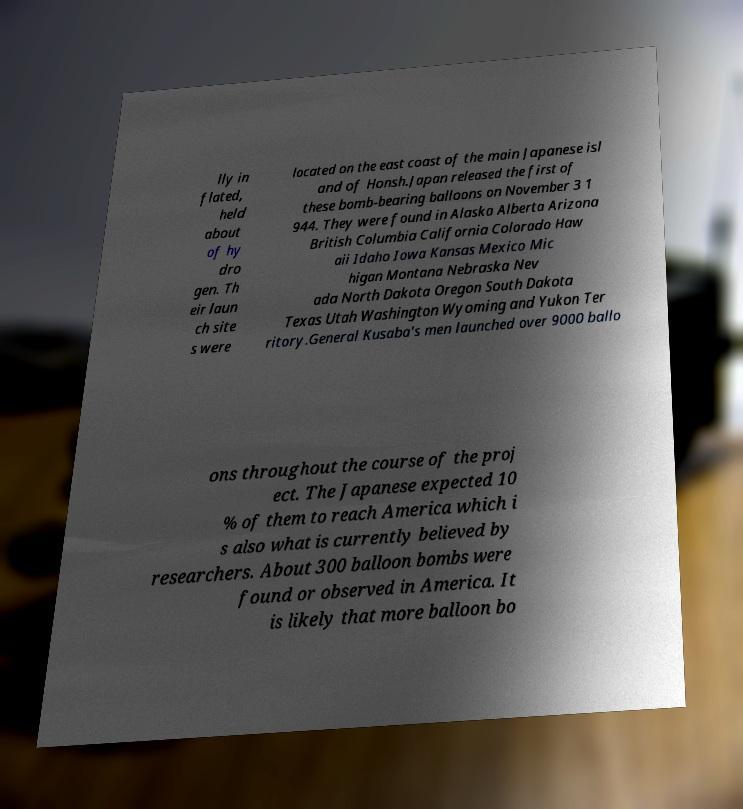I need the written content from this picture converted into text. Can you do that? lly in flated, held about of hy dro gen. Th eir laun ch site s were located on the east coast of the main Japanese isl and of Honsh.Japan released the first of these bomb-bearing balloons on November 3 1 944. They were found in Alaska Alberta Arizona British Columbia California Colorado Haw aii Idaho Iowa Kansas Mexico Mic higan Montana Nebraska Nev ada North Dakota Oregon South Dakota Texas Utah Washington Wyoming and Yukon Ter ritory.General Kusaba's men launched over 9000 ballo ons throughout the course of the proj ect. The Japanese expected 10 % of them to reach America which i s also what is currently believed by researchers. About 300 balloon bombs were found or observed in America. It is likely that more balloon bo 